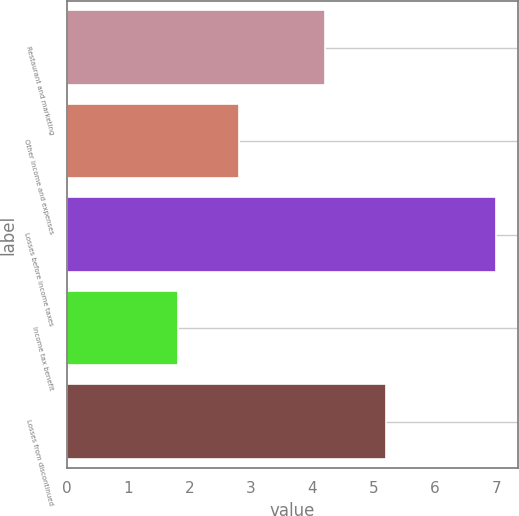Convert chart to OTSL. <chart><loc_0><loc_0><loc_500><loc_500><bar_chart><fcel>Restaurant and marketing<fcel>Other income and expenses<fcel>Losses before income taxes<fcel>Income tax benefit<fcel>Losses from discontinued<nl><fcel>4.2<fcel>2.8<fcel>7<fcel>1.8<fcel>5.2<nl></chart> 